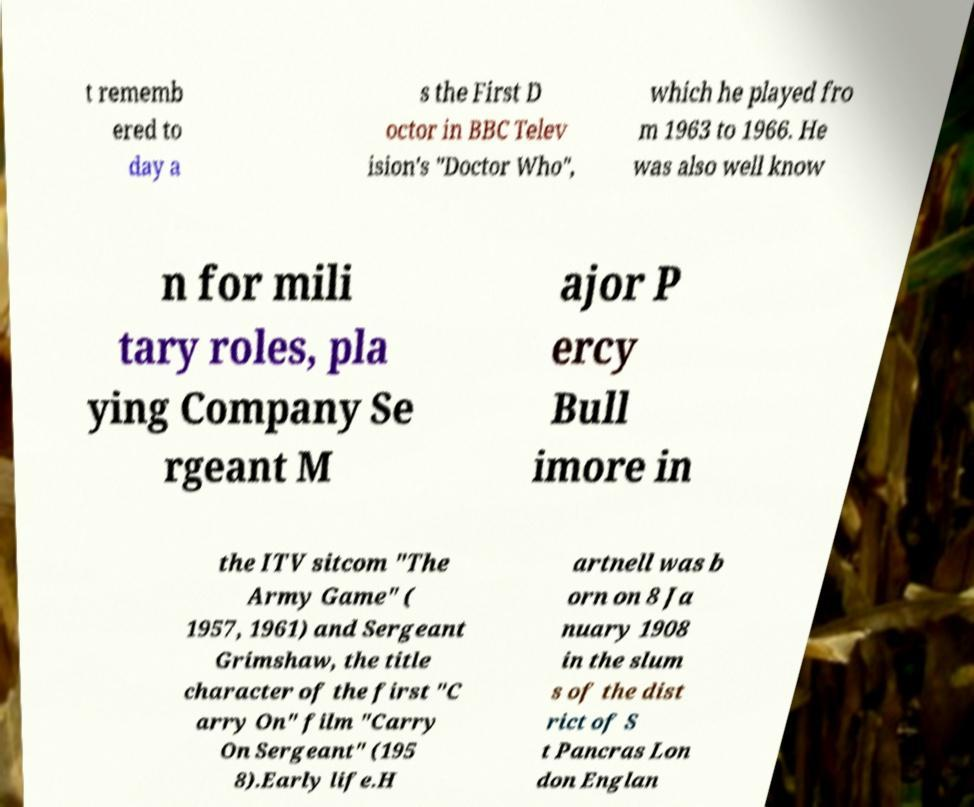I need the written content from this picture converted into text. Can you do that? t rememb ered to day a s the First D octor in BBC Telev ision's "Doctor Who", which he played fro m 1963 to 1966. He was also well know n for mili tary roles, pla ying Company Se rgeant M ajor P ercy Bull imore in the ITV sitcom "The Army Game" ( 1957, 1961) and Sergeant Grimshaw, the title character of the first "C arry On" film "Carry On Sergeant" (195 8).Early life.H artnell was b orn on 8 Ja nuary 1908 in the slum s of the dist rict of S t Pancras Lon don Englan 